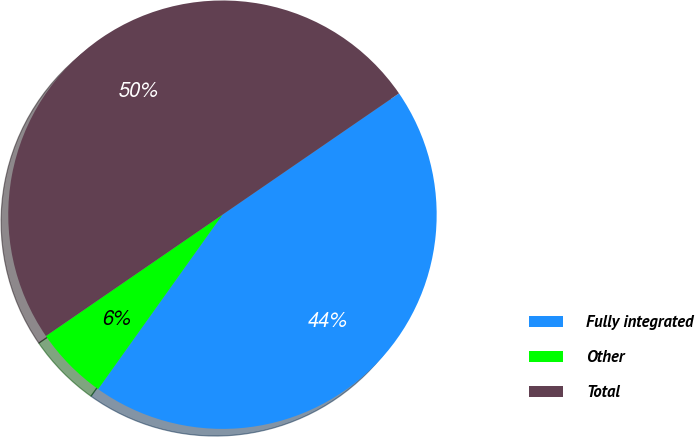Convert chart to OTSL. <chart><loc_0><loc_0><loc_500><loc_500><pie_chart><fcel>Fully integrated<fcel>Other<fcel>Total<nl><fcel>44.44%<fcel>5.56%<fcel>50.0%<nl></chart> 